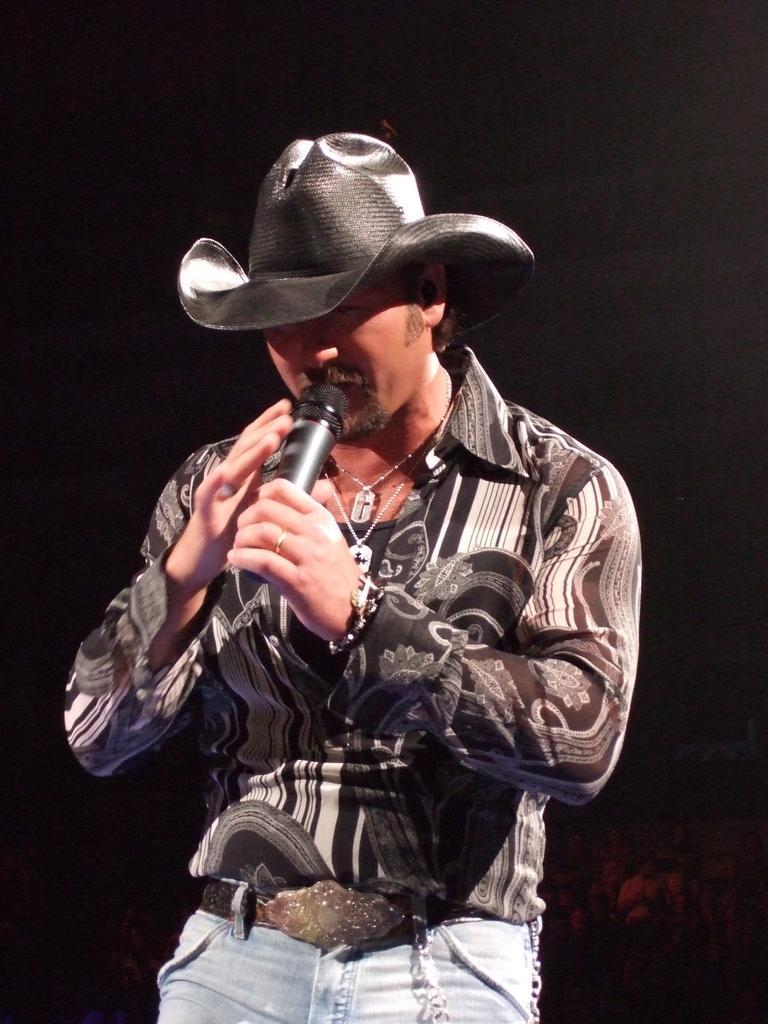In one or two sentences, can you explain what this image depicts? Here we can see a man standing and holding a microphone in his hands. 